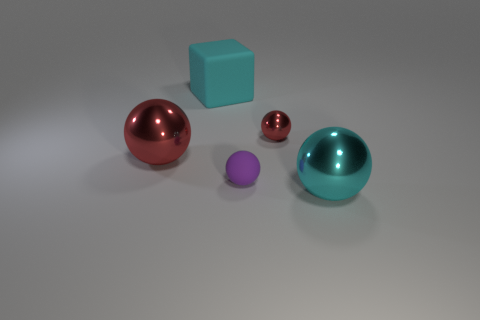Add 1 matte spheres. How many objects exist? 6 Subtract all purple balls. How many balls are left? 3 Add 2 cyan metal spheres. How many cyan metal spheres exist? 3 Subtract all cyan spheres. How many spheres are left? 3 Subtract 0 green cubes. How many objects are left? 5 Subtract all balls. How many objects are left? 1 Subtract 1 cubes. How many cubes are left? 0 Subtract all blue cubes. Subtract all green cylinders. How many cubes are left? 1 Subtract all cyan cylinders. How many purple spheres are left? 1 Subtract all green metallic cubes. Subtract all cyan objects. How many objects are left? 3 